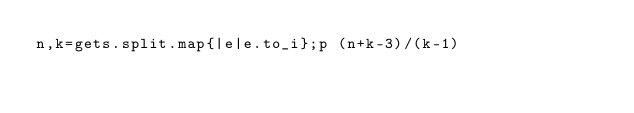Convert code to text. <code><loc_0><loc_0><loc_500><loc_500><_Ruby_>n,k=gets.split.map{|e|e.to_i};p (n+k-3)/(k-1)</code> 